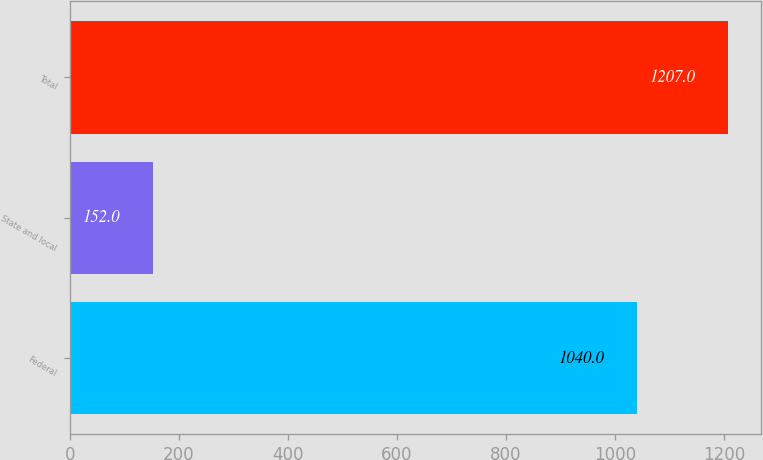<chart> <loc_0><loc_0><loc_500><loc_500><bar_chart><fcel>Federal<fcel>State and local<fcel>Total<nl><fcel>1040<fcel>152<fcel>1207<nl></chart> 